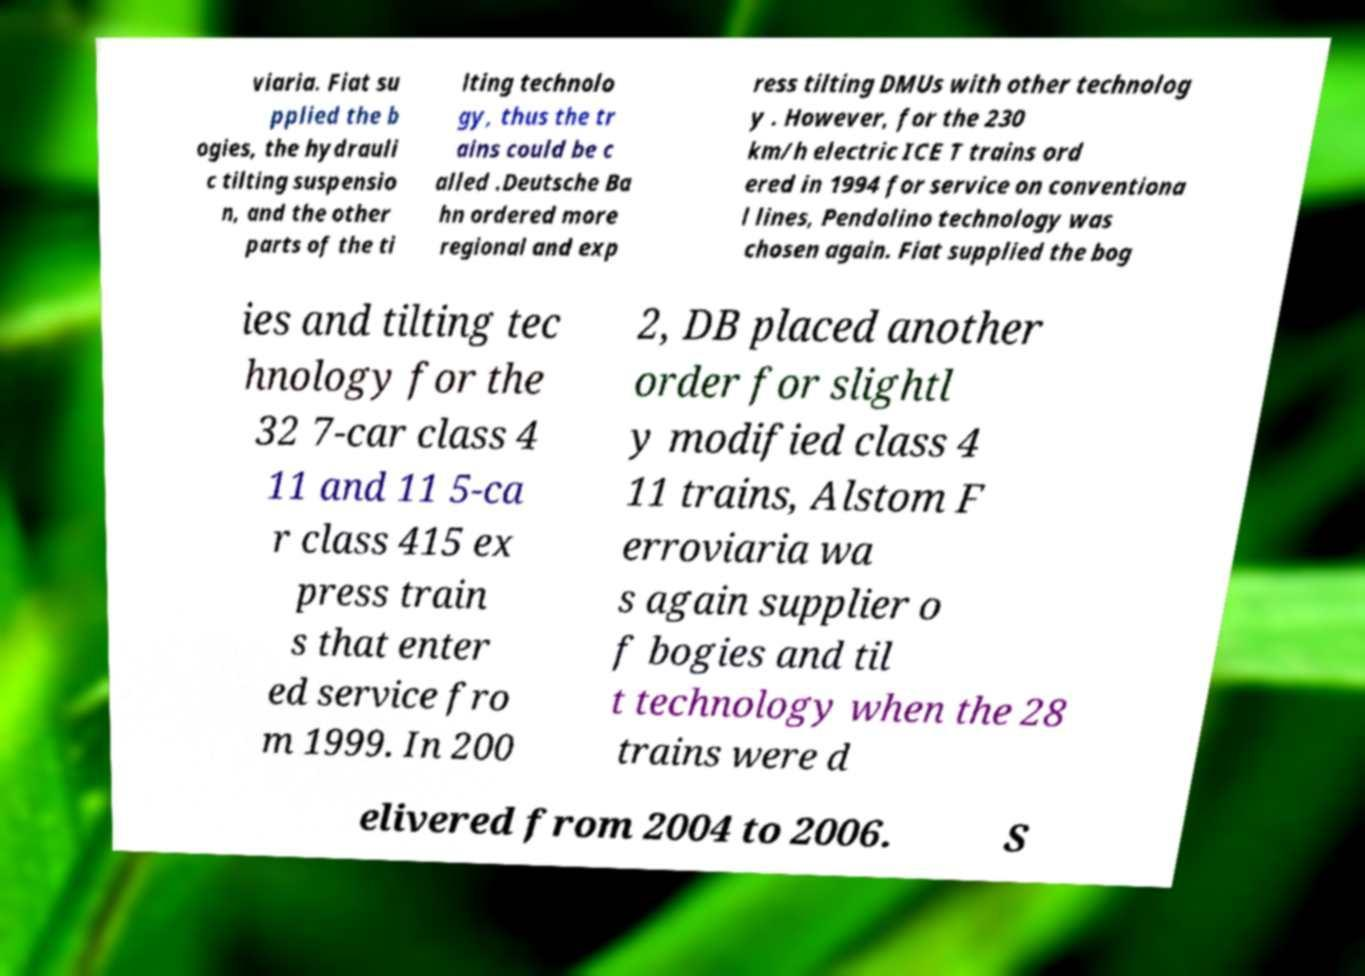What messages or text are displayed in this image? I need them in a readable, typed format. viaria. Fiat su pplied the b ogies, the hydrauli c tilting suspensio n, and the other parts of the ti lting technolo gy, thus the tr ains could be c alled .Deutsche Ba hn ordered more regional and exp ress tilting DMUs with other technolog y . However, for the 230 km/h electric ICE T trains ord ered in 1994 for service on conventiona l lines, Pendolino technology was chosen again. Fiat supplied the bog ies and tilting tec hnology for the 32 7-car class 4 11 and 11 5-ca r class 415 ex press train s that enter ed service fro m 1999. In 200 2, DB placed another order for slightl y modified class 4 11 trains, Alstom F erroviaria wa s again supplier o f bogies and til t technology when the 28 trains were d elivered from 2004 to 2006. S 